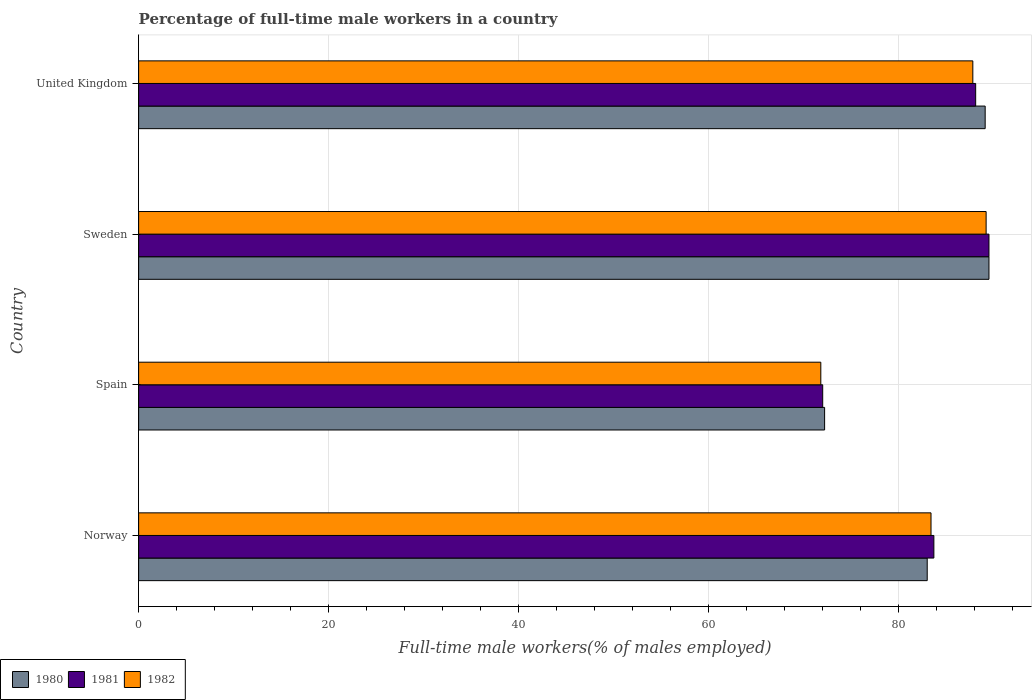How many groups of bars are there?
Offer a terse response. 4. How many bars are there on the 4th tick from the bottom?
Ensure brevity in your answer.  3. What is the label of the 1st group of bars from the top?
Make the answer very short. United Kingdom. What is the percentage of full-time male workers in 1982 in Spain?
Give a very brief answer. 71.8. Across all countries, what is the maximum percentage of full-time male workers in 1980?
Keep it short and to the point. 89.5. Across all countries, what is the minimum percentage of full-time male workers in 1982?
Provide a short and direct response. 71.8. What is the total percentage of full-time male workers in 1980 in the graph?
Keep it short and to the point. 333.8. What is the difference between the percentage of full-time male workers in 1982 in Norway and that in Sweden?
Give a very brief answer. -5.8. What is the difference between the percentage of full-time male workers in 1981 in Spain and the percentage of full-time male workers in 1982 in Norway?
Provide a short and direct response. -11.4. What is the average percentage of full-time male workers in 1980 per country?
Give a very brief answer. 83.45. What is the difference between the percentage of full-time male workers in 1981 and percentage of full-time male workers in 1982 in Sweden?
Offer a terse response. 0.3. What is the ratio of the percentage of full-time male workers in 1980 in Sweden to that in United Kingdom?
Offer a terse response. 1. Is the percentage of full-time male workers in 1982 in Norway less than that in Sweden?
Offer a terse response. Yes. Is the difference between the percentage of full-time male workers in 1981 in Spain and United Kingdom greater than the difference between the percentage of full-time male workers in 1982 in Spain and United Kingdom?
Provide a succinct answer. No. What is the difference between the highest and the second highest percentage of full-time male workers in 1980?
Keep it short and to the point. 0.4. What is the difference between the highest and the lowest percentage of full-time male workers in 1982?
Your answer should be very brief. 17.4. Is the sum of the percentage of full-time male workers in 1980 in Spain and United Kingdom greater than the maximum percentage of full-time male workers in 1981 across all countries?
Give a very brief answer. Yes. What does the 2nd bar from the top in Norway represents?
Ensure brevity in your answer.  1981. Are all the bars in the graph horizontal?
Provide a short and direct response. Yes. How many countries are there in the graph?
Offer a very short reply. 4. Are the values on the major ticks of X-axis written in scientific E-notation?
Provide a succinct answer. No. Does the graph contain any zero values?
Offer a terse response. No. Does the graph contain grids?
Offer a terse response. Yes. How many legend labels are there?
Provide a succinct answer. 3. What is the title of the graph?
Your answer should be very brief. Percentage of full-time male workers in a country. What is the label or title of the X-axis?
Give a very brief answer. Full-time male workers(% of males employed). What is the Full-time male workers(% of males employed) in 1980 in Norway?
Ensure brevity in your answer.  83. What is the Full-time male workers(% of males employed) in 1981 in Norway?
Your answer should be compact. 83.7. What is the Full-time male workers(% of males employed) in 1982 in Norway?
Your response must be concise. 83.4. What is the Full-time male workers(% of males employed) of 1980 in Spain?
Your answer should be very brief. 72.2. What is the Full-time male workers(% of males employed) in 1981 in Spain?
Provide a short and direct response. 72. What is the Full-time male workers(% of males employed) of 1982 in Spain?
Keep it short and to the point. 71.8. What is the Full-time male workers(% of males employed) of 1980 in Sweden?
Offer a very short reply. 89.5. What is the Full-time male workers(% of males employed) of 1981 in Sweden?
Your response must be concise. 89.5. What is the Full-time male workers(% of males employed) in 1982 in Sweden?
Provide a short and direct response. 89.2. What is the Full-time male workers(% of males employed) of 1980 in United Kingdom?
Give a very brief answer. 89.1. What is the Full-time male workers(% of males employed) of 1981 in United Kingdom?
Provide a short and direct response. 88.1. What is the Full-time male workers(% of males employed) of 1982 in United Kingdom?
Offer a terse response. 87.8. Across all countries, what is the maximum Full-time male workers(% of males employed) in 1980?
Provide a short and direct response. 89.5. Across all countries, what is the maximum Full-time male workers(% of males employed) in 1981?
Your answer should be compact. 89.5. Across all countries, what is the maximum Full-time male workers(% of males employed) of 1982?
Your answer should be very brief. 89.2. Across all countries, what is the minimum Full-time male workers(% of males employed) in 1980?
Your answer should be compact. 72.2. Across all countries, what is the minimum Full-time male workers(% of males employed) of 1982?
Provide a succinct answer. 71.8. What is the total Full-time male workers(% of males employed) in 1980 in the graph?
Your answer should be compact. 333.8. What is the total Full-time male workers(% of males employed) of 1981 in the graph?
Offer a very short reply. 333.3. What is the total Full-time male workers(% of males employed) in 1982 in the graph?
Keep it short and to the point. 332.2. What is the difference between the Full-time male workers(% of males employed) of 1980 in Norway and that in Spain?
Your answer should be compact. 10.8. What is the difference between the Full-time male workers(% of males employed) in 1981 in Norway and that in Spain?
Your answer should be compact. 11.7. What is the difference between the Full-time male workers(% of males employed) in 1980 in Norway and that in Sweden?
Your answer should be compact. -6.5. What is the difference between the Full-time male workers(% of males employed) of 1982 in Norway and that in Sweden?
Give a very brief answer. -5.8. What is the difference between the Full-time male workers(% of males employed) of 1982 in Norway and that in United Kingdom?
Keep it short and to the point. -4.4. What is the difference between the Full-time male workers(% of males employed) of 1980 in Spain and that in Sweden?
Ensure brevity in your answer.  -17.3. What is the difference between the Full-time male workers(% of males employed) of 1981 in Spain and that in Sweden?
Offer a terse response. -17.5. What is the difference between the Full-time male workers(% of males employed) in 1982 in Spain and that in Sweden?
Provide a succinct answer. -17.4. What is the difference between the Full-time male workers(% of males employed) of 1980 in Spain and that in United Kingdom?
Provide a short and direct response. -16.9. What is the difference between the Full-time male workers(% of males employed) in 1981 in Spain and that in United Kingdom?
Offer a terse response. -16.1. What is the difference between the Full-time male workers(% of males employed) in 1982 in Spain and that in United Kingdom?
Your answer should be compact. -16. What is the difference between the Full-time male workers(% of males employed) of 1982 in Sweden and that in United Kingdom?
Provide a succinct answer. 1.4. What is the difference between the Full-time male workers(% of males employed) of 1980 in Norway and the Full-time male workers(% of males employed) of 1981 in Spain?
Ensure brevity in your answer.  11. What is the difference between the Full-time male workers(% of males employed) of 1980 in Norway and the Full-time male workers(% of males employed) of 1982 in Spain?
Your answer should be compact. 11.2. What is the difference between the Full-time male workers(% of males employed) of 1980 in Norway and the Full-time male workers(% of males employed) of 1982 in Sweden?
Offer a very short reply. -6.2. What is the difference between the Full-time male workers(% of males employed) in 1980 in Norway and the Full-time male workers(% of males employed) in 1982 in United Kingdom?
Provide a short and direct response. -4.8. What is the difference between the Full-time male workers(% of males employed) of 1980 in Spain and the Full-time male workers(% of males employed) of 1981 in Sweden?
Keep it short and to the point. -17.3. What is the difference between the Full-time male workers(% of males employed) in 1980 in Spain and the Full-time male workers(% of males employed) in 1982 in Sweden?
Your response must be concise. -17. What is the difference between the Full-time male workers(% of males employed) in 1981 in Spain and the Full-time male workers(% of males employed) in 1982 in Sweden?
Offer a terse response. -17.2. What is the difference between the Full-time male workers(% of males employed) of 1980 in Spain and the Full-time male workers(% of males employed) of 1981 in United Kingdom?
Your answer should be compact. -15.9. What is the difference between the Full-time male workers(% of males employed) of 1980 in Spain and the Full-time male workers(% of males employed) of 1982 in United Kingdom?
Your answer should be very brief. -15.6. What is the difference between the Full-time male workers(% of males employed) in 1981 in Spain and the Full-time male workers(% of males employed) in 1982 in United Kingdom?
Provide a short and direct response. -15.8. What is the difference between the Full-time male workers(% of males employed) in 1980 in Sweden and the Full-time male workers(% of males employed) in 1981 in United Kingdom?
Keep it short and to the point. 1.4. What is the difference between the Full-time male workers(% of males employed) in 1980 in Sweden and the Full-time male workers(% of males employed) in 1982 in United Kingdom?
Offer a terse response. 1.7. What is the difference between the Full-time male workers(% of males employed) of 1981 in Sweden and the Full-time male workers(% of males employed) of 1982 in United Kingdom?
Keep it short and to the point. 1.7. What is the average Full-time male workers(% of males employed) in 1980 per country?
Your response must be concise. 83.45. What is the average Full-time male workers(% of males employed) in 1981 per country?
Your response must be concise. 83.33. What is the average Full-time male workers(% of males employed) in 1982 per country?
Keep it short and to the point. 83.05. What is the difference between the Full-time male workers(% of males employed) of 1981 and Full-time male workers(% of males employed) of 1982 in Norway?
Provide a succinct answer. 0.3. What is the difference between the Full-time male workers(% of males employed) of 1980 and Full-time male workers(% of males employed) of 1981 in Spain?
Your answer should be very brief. 0.2. What is the difference between the Full-time male workers(% of males employed) of 1980 and Full-time male workers(% of males employed) of 1982 in Spain?
Ensure brevity in your answer.  0.4. What is the difference between the Full-time male workers(% of males employed) in 1981 and Full-time male workers(% of males employed) in 1982 in Spain?
Your answer should be compact. 0.2. What is the difference between the Full-time male workers(% of males employed) in 1980 and Full-time male workers(% of males employed) in 1981 in Sweden?
Provide a succinct answer. 0. What is the difference between the Full-time male workers(% of males employed) of 1981 and Full-time male workers(% of males employed) of 1982 in Sweden?
Provide a short and direct response. 0.3. What is the difference between the Full-time male workers(% of males employed) in 1980 and Full-time male workers(% of males employed) in 1981 in United Kingdom?
Your answer should be very brief. 1. What is the ratio of the Full-time male workers(% of males employed) in 1980 in Norway to that in Spain?
Offer a very short reply. 1.15. What is the ratio of the Full-time male workers(% of males employed) of 1981 in Norway to that in Spain?
Provide a short and direct response. 1.16. What is the ratio of the Full-time male workers(% of males employed) of 1982 in Norway to that in Spain?
Keep it short and to the point. 1.16. What is the ratio of the Full-time male workers(% of males employed) in 1980 in Norway to that in Sweden?
Provide a short and direct response. 0.93. What is the ratio of the Full-time male workers(% of males employed) of 1981 in Norway to that in Sweden?
Give a very brief answer. 0.94. What is the ratio of the Full-time male workers(% of males employed) of 1982 in Norway to that in Sweden?
Your answer should be very brief. 0.94. What is the ratio of the Full-time male workers(% of males employed) of 1980 in Norway to that in United Kingdom?
Give a very brief answer. 0.93. What is the ratio of the Full-time male workers(% of males employed) of 1981 in Norway to that in United Kingdom?
Give a very brief answer. 0.95. What is the ratio of the Full-time male workers(% of males employed) in 1982 in Norway to that in United Kingdom?
Ensure brevity in your answer.  0.95. What is the ratio of the Full-time male workers(% of males employed) in 1980 in Spain to that in Sweden?
Offer a terse response. 0.81. What is the ratio of the Full-time male workers(% of males employed) in 1981 in Spain to that in Sweden?
Provide a succinct answer. 0.8. What is the ratio of the Full-time male workers(% of males employed) in 1982 in Spain to that in Sweden?
Ensure brevity in your answer.  0.8. What is the ratio of the Full-time male workers(% of males employed) in 1980 in Spain to that in United Kingdom?
Offer a very short reply. 0.81. What is the ratio of the Full-time male workers(% of males employed) in 1981 in Spain to that in United Kingdom?
Your response must be concise. 0.82. What is the ratio of the Full-time male workers(% of males employed) in 1982 in Spain to that in United Kingdom?
Your answer should be very brief. 0.82. What is the ratio of the Full-time male workers(% of males employed) in 1980 in Sweden to that in United Kingdom?
Offer a terse response. 1. What is the ratio of the Full-time male workers(% of males employed) in 1981 in Sweden to that in United Kingdom?
Ensure brevity in your answer.  1.02. What is the ratio of the Full-time male workers(% of males employed) of 1982 in Sweden to that in United Kingdom?
Ensure brevity in your answer.  1.02. What is the difference between the highest and the second highest Full-time male workers(% of males employed) of 1980?
Provide a succinct answer. 0.4. What is the difference between the highest and the second highest Full-time male workers(% of males employed) of 1982?
Offer a very short reply. 1.4. What is the difference between the highest and the lowest Full-time male workers(% of males employed) in 1980?
Ensure brevity in your answer.  17.3. What is the difference between the highest and the lowest Full-time male workers(% of males employed) of 1982?
Your answer should be very brief. 17.4. 